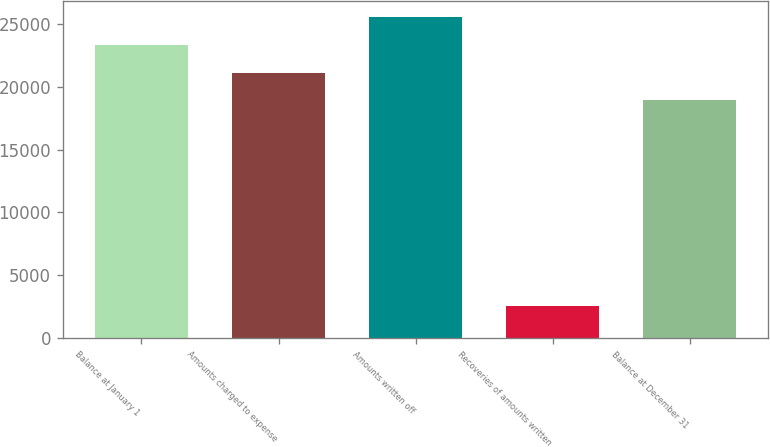<chart> <loc_0><loc_0><loc_500><loc_500><bar_chart><fcel>Balance at January 1<fcel>Amounts charged to expense<fcel>Amounts written off<fcel>Recoveries of amounts written<fcel>Balance at December 31<nl><fcel>23340<fcel>21122.5<fcel>25557.5<fcel>2566<fcel>18905<nl></chart> 